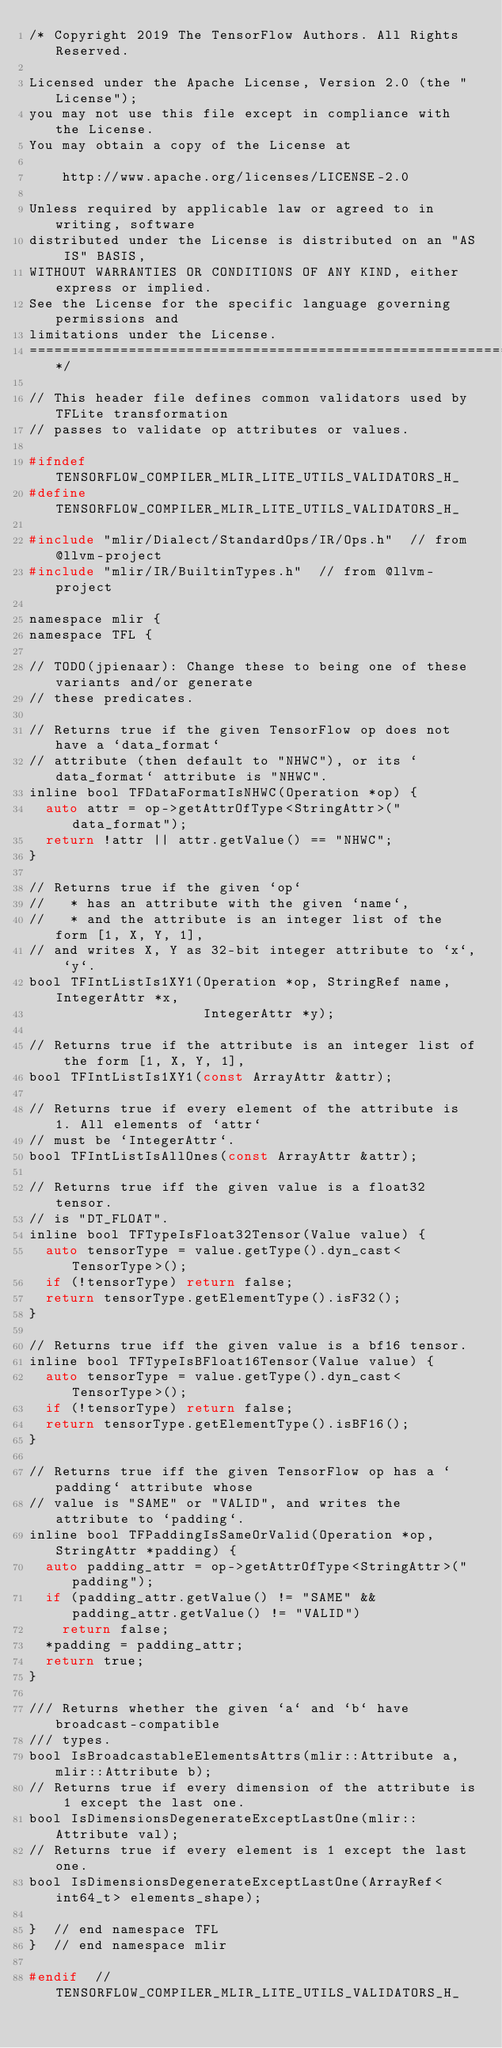<code> <loc_0><loc_0><loc_500><loc_500><_C_>/* Copyright 2019 The TensorFlow Authors. All Rights Reserved.

Licensed under the Apache License, Version 2.0 (the "License");
you may not use this file except in compliance with the License.
You may obtain a copy of the License at

    http://www.apache.org/licenses/LICENSE-2.0

Unless required by applicable law or agreed to in writing, software
distributed under the License is distributed on an "AS IS" BASIS,
WITHOUT WARRANTIES OR CONDITIONS OF ANY KIND, either express or implied.
See the License for the specific language governing permissions and
limitations under the License.
==============================================================================*/

// This header file defines common validators used by TFLite transformation
// passes to validate op attributes or values.

#ifndef TENSORFLOW_COMPILER_MLIR_LITE_UTILS_VALIDATORS_H_
#define TENSORFLOW_COMPILER_MLIR_LITE_UTILS_VALIDATORS_H_

#include "mlir/Dialect/StandardOps/IR/Ops.h"  // from @llvm-project
#include "mlir/IR/BuiltinTypes.h"  // from @llvm-project

namespace mlir {
namespace TFL {

// TODO(jpienaar): Change these to being one of these variants and/or generate
// these predicates.

// Returns true if the given TensorFlow op does not have a `data_format`
// attribute (then default to "NHWC"), or its `data_format` attribute is "NHWC".
inline bool TFDataFormatIsNHWC(Operation *op) {
  auto attr = op->getAttrOfType<StringAttr>("data_format");
  return !attr || attr.getValue() == "NHWC";
}

// Returns true if the given `op`
//   * has an attribute with the given `name`,
//   * and the attribute is an integer list of the form [1, X, Y, 1],
// and writes X, Y as 32-bit integer attribute to `x`, `y`.
bool TFIntListIs1XY1(Operation *op, StringRef name, IntegerAttr *x,
                     IntegerAttr *y);

// Returns true if the attribute is an integer list of the form [1, X, Y, 1],
bool TFIntListIs1XY1(const ArrayAttr &attr);

// Returns true if every element of the attribute is 1. All elements of `attr`
// must be `IntegerAttr`.
bool TFIntListIsAllOnes(const ArrayAttr &attr);

// Returns true iff the given value is a float32 tensor.
// is "DT_FLOAT".
inline bool TFTypeIsFloat32Tensor(Value value) {
  auto tensorType = value.getType().dyn_cast<TensorType>();
  if (!tensorType) return false;
  return tensorType.getElementType().isF32();
}

// Returns true iff the given value is a bf16 tensor.
inline bool TFTypeIsBFloat16Tensor(Value value) {
  auto tensorType = value.getType().dyn_cast<TensorType>();
  if (!tensorType) return false;
  return tensorType.getElementType().isBF16();
}

// Returns true iff the given TensorFlow op has a `padding` attribute whose
// value is "SAME" or "VALID", and writes the attribute to `padding`.
inline bool TFPaddingIsSameOrValid(Operation *op, StringAttr *padding) {
  auto padding_attr = op->getAttrOfType<StringAttr>("padding");
  if (padding_attr.getValue() != "SAME" && padding_attr.getValue() != "VALID")
    return false;
  *padding = padding_attr;
  return true;
}

/// Returns whether the given `a` and `b` have broadcast-compatible
/// types.
bool IsBroadcastableElementsAttrs(mlir::Attribute a, mlir::Attribute b);
// Returns true if every dimension of the attribute is 1 except the last one.
bool IsDimensionsDegenerateExceptLastOne(mlir::Attribute val);
// Returns true if every element is 1 except the last one.
bool IsDimensionsDegenerateExceptLastOne(ArrayRef<int64_t> elements_shape);

}  // end namespace TFL
}  // end namespace mlir

#endif  // TENSORFLOW_COMPILER_MLIR_LITE_UTILS_VALIDATORS_H_
</code> 